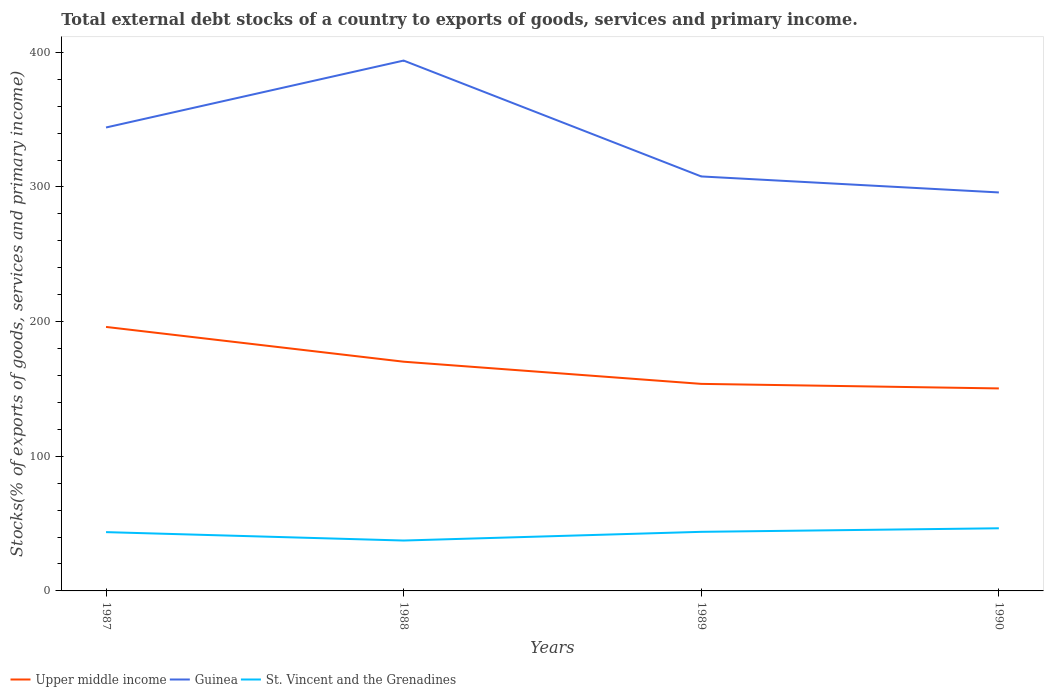How many different coloured lines are there?
Your answer should be very brief. 3. Across all years, what is the maximum total debt stocks in St. Vincent and the Grenadines?
Your answer should be very brief. 37.43. What is the total total debt stocks in St. Vincent and the Grenadines in the graph?
Offer a very short reply. -0.23. What is the difference between the highest and the second highest total debt stocks in Upper middle income?
Your answer should be very brief. 45.66. What is the difference between the highest and the lowest total debt stocks in St. Vincent and the Grenadines?
Make the answer very short. 3. How many lines are there?
Provide a short and direct response. 3. How many years are there in the graph?
Keep it short and to the point. 4. What is the difference between two consecutive major ticks on the Y-axis?
Make the answer very short. 100. Does the graph contain any zero values?
Provide a short and direct response. No. Does the graph contain grids?
Ensure brevity in your answer.  No. How many legend labels are there?
Offer a terse response. 3. What is the title of the graph?
Give a very brief answer. Total external debt stocks of a country to exports of goods, services and primary income. What is the label or title of the X-axis?
Make the answer very short. Years. What is the label or title of the Y-axis?
Make the answer very short. Stocks(% of exports of goods, services and primary income). What is the Stocks(% of exports of goods, services and primary income) in Upper middle income in 1987?
Offer a terse response. 196.06. What is the Stocks(% of exports of goods, services and primary income) of Guinea in 1987?
Ensure brevity in your answer.  344.19. What is the Stocks(% of exports of goods, services and primary income) in St. Vincent and the Grenadines in 1987?
Your answer should be very brief. 43.66. What is the Stocks(% of exports of goods, services and primary income) of Upper middle income in 1988?
Keep it short and to the point. 170.24. What is the Stocks(% of exports of goods, services and primary income) in Guinea in 1988?
Keep it short and to the point. 393.89. What is the Stocks(% of exports of goods, services and primary income) in St. Vincent and the Grenadines in 1988?
Provide a succinct answer. 37.43. What is the Stocks(% of exports of goods, services and primary income) in Upper middle income in 1989?
Make the answer very short. 153.77. What is the Stocks(% of exports of goods, services and primary income) in Guinea in 1989?
Offer a very short reply. 307.83. What is the Stocks(% of exports of goods, services and primary income) of St. Vincent and the Grenadines in 1989?
Your answer should be very brief. 43.89. What is the Stocks(% of exports of goods, services and primary income) in Upper middle income in 1990?
Offer a very short reply. 150.4. What is the Stocks(% of exports of goods, services and primary income) of Guinea in 1990?
Give a very brief answer. 295.95. What is the Stocks(% of exports of goods, services and primary income) in St. Vincent and the Grenadines in 1990?
Make the answer very short. 46.52. Across all years, what is the maximum Stocks(% of exports of goods, services and primary income) of Upper middle income?
Provide a succinct answer. 196.06. Across all years, what is the maximum Stocks(% of exports of goods, services and primary income) of Guinea?
Provide a succinct answer. 393.89. Across all years, what is the maximum Stocks(% of exports of goods, services and primary income) in St. Vincent and the Grenadines?
Give a very brief answer. 46.52. Across all years, what is the minimum Stocks(% of exports of goods, services and primary income) of Upper middle income?
Offer a very short reply. 150.4. Across all years, what is the minimum Stocks(% of exports of goods, services and primary income) in Guinea?
Your answer should be compact. 295.95. Across all years, what is the minimum Stocks(% of exports of goods, services and primary income) in St. Vincent and the Grenadines?
Ensure brevity in your answer.  37.43. What is the total Stocks(% of exports of goods, services and primary income) in Upper middle income in the graph?
Offer a terse response. 670.47. What is the total Stocks(% of exports of goods, services and primary income) of Guinea in the graph?
Your answer should be very brief. 1341.86. What is the total Stocks(% of exports of goods, services and primary income) of St. Vincent and the Grenadines in the graph?
Provide a short and direct response. 171.51. What is the difference between the Stocks(% of exports of goods, services and primary income) of Upper middle income in 1987 and that in 1988?
Offer a terse response. 25.82. What is the difference between the Stocks(% of exports of goods, services and primary income) in Guinea in 1987 and that in 1988?
Your answer should be compact. -49.7. What is the difference between the Stocks(% of exports of goods, services and primary income) in St. Vincent and the Grenadines in 1987 and that in 1988?
Your answer should be very brief. 6.23. What is the difference between the Stocks(% of exports of goods, services and primary income) of Upper middle income in 1987 and that in 1989?
Your answer should be compact. 42.29. What is the difference between the Stocks(% of exports of goods, services and primary income) of Guinea in 1987 and that in 1989?
Give a very brief answer. 36.36. What is the difference between the Stocks(% of exports of goods, services and primary income) in St. Vincent and the Grenadines in 1987 and that in 1989?
Offer a very short reply. -0.23. What is the difference between the Stocks(% of exports of goods, services and primary income) of Upper middle income in 1987 and that in 1990?
Offer a terse response. 45.66. What is the difference between the Stocks(% of exports of goods, services and primary income) of Guinea in 1987 and that in 1990?
Your answer should be very brief. 48.24. What is the difference between the Stocks(% of exports of goods, services and primary income) of St. Vincent and the Grenadines in 1987 and that in 1990?
Offer a terse response. -2.86. What is the difference between the Stocks(% of exports of goods, services and primary income) in Upper middle income in 1988 and that in 1989?
Provide a short and direct response. 16.47. What is the difference between the Stocks(% of exports of goods, services and primary income) of Guinea in 1988 and that in 1989?
Your response must be concise. 86.06. What is the difference between the Stocks(% of exports of goods, services and primary income) of St. Vincent and the Grenadines in 1988 and that in 1989?
Your response must be concise. -6.46. What is the difference between the Stocks(% of exports of goods, services and primary income) of Upper middle income in 1988 and that in 1990?
Your answer should be very brief. 19.84. What is the difference between the Stocks(% of exports of goods, services and primary income) of Guinea in 1988 and that in 1990?
Your answer should be compact. 97.94. What is the difference between the Stocks(% of exports of goods, services and primary income) in St. Vincent and the Grenadines in 1988 and that in 1990?
Your answer should be compact. -9.09. What is the difference between the Stocks(% of exports of goods, services and primary income) in Upper middle income in 1989 and that in 1990?
Offer a terse response. 3.37. What is the difference between the Stocks(% of exports of goods, services and primary income) of Guinea in 1989 and that in 1990?
Ensure brevity in your answer.  11.88. What is the difference between the Stocks(% of exports of goods, services and primary income) in St. Vincent and the Grenadines in 1989 and that in 1990?
Give a very brief answer. -2.63. What is the difference between the Stocks(% of exports of goods, services and primary income) in Upper middle income in 1987 and the Stocks(% of exports of goods, services and primary income) in Guinea in 1988?
Offer a terse response. -197.83. What is the difference between the Stocks(% of exports of goods, services and primary income) of Upper middle income in 1987 and the Stocks(% of exports of goods, services and primary income) of St. Vincent and the Grenadines in 1988?
Ensure brevity in your answer.  158.63. What is the difference between the Stocks(% of exports of goods, services and primary income) of Guinea in 1987 and the Stocks(% of exports of goods, services and primary income) of St. Vincent and the Grenadines in 1988?
Your response must be concise. 306.76. What is the difference between the Stocks(% of exports of goods, services and primary income) in Upper middle income in 1987 and the Stocks(% of exports of goods, services and primary income) in Guinea in 1989?
Provide a succinct answer. -111.77. What is the difference between the Stocks(% of exports of goods, services and primary income) in Upper middle income in 1987 and the Stocks(% of exports of goods, services and primary income) in St. Vincent and the Grenadines in 1989?
Offer a terse response. 152.17. What is the difference between the Stocks(% of exports of goods, services and primary income) in Guinea in 1987 and the Stocks(% of exports of goods, services and primary income) in St. Vincent and the Grenadines in 1989?
Keep it short and to the point. 300.3. What is the difference between the Stocks(% of exports of goods, services and primary income) in Upper middle income in 1987 and the Stocks(% of exports of goods, services and primary income) in Guinea in 1990?
Keep it short and to the point. -99.89. What is the difference between the Stocks(% of exports of goods, services and primary income) of Upper middle income in 1987 and the Stocks(% of exports of goods, services and primary income) of St. Vincent and the Grenadines in 1990?
Make the answer very short. 149.54. What is the difference between the Stocks(% of exports of goods, services and primary income) in Guinea in 1987 and the Stocks(% of exports of goods, services and primary income) in St. Vincent and the Grenadines in 1990?
Keep it short and to the point. 297.67. What is the difference between the Stocks(% of exports of goods, services and primary income) of Upper middle income in 1988 and the Stocks(% of exports of goods, services and primary income) of Guinea in 1989?
Provide a short and direct response. -137.59. What is the difference between the Stocks(% of exports of goods, services and primary income) in Upper middle income in 1988 and the Stocks(% of exports of goods, services and primary income) in St. Vincent and the Grenadines in 1989?
Provide a succinct answer. 126.35. What is the difference between the Stocks(% of exports of goods, services and primary income) in Guinea in 1988 and the Stocks(% of exports of goods, services and primary income) in St. Vincent and the Grenadines in 1989?
Make the answer very short. 350. What is the difference between the Stocks(% of exports of goods, services and primary income) in Upper middle income in 1988 and the Stocks(% of exports of goods, services and primary income) in Guinea in 1990?
Provide a succinct answer. -125.71. What is the difference between the Stocks(% of exports of goods, services and primary income) in Upper middle income in 1988 and the Stocks(% of exports of goods, services and primary income) in St. Vincent and the Grenadines in 1990?
Make the answer very short. 123.72. What is the difference between the Stocks(% of exports of goods, services and primary income) of Guinea in 1988 and the Stocks(% of exports of goods, services and primary income) of St. Vincent and the Grenadines in 1990?
Ensure brevity in your answer.  347.37. What is the difference between the Stocks(% of exports of goods, services and primary income) of Upper middle income in 1989 and the Stocks(% of exports of goods, services and primary income) of Guinea in 1990?
Offer a very short reply. -142.18. What is the difference between the Stocks(% of exports of goods, services and primary income) in Upper middle income in 1989 and the Stocks(% of exports of goods, services and primary income) in St. Vincent and the Grenadines in 1990?
Your answer should be compact. 107.25. What is the difference between the Stocks(% of exports of goods, services and primary income) in Guinea in 1989 and the Stocks(% of exports of goods, services and primary income) in St. Vincent and the Grenadines in 1990?
Provide a short and direct response. 261.31. What is the average Stocks(% of exports of goods, services and primary income) in Upper middle income per year?
Make the answer very short. 167.62. What is the average Stocks(% of exports of goods, services and primary income) in Guinea per year?
Give a very brief answer. 335.46. What is the average Stocks(% of exports of goods, services and primary income) of St. Vincent and the Grenadines per year?
Your answer should be very brief. 42.88. In the year 1987, what is the difference between the Stocks(% of exports of goods, services and primary income) in Upper middle income and Stocks(% of exports of goods, services and primary income) in Guinea?
Provide a succinct answer. -148.13. In the year 1987, what is the difference between the Stocks(% of exports of goods, services and primary income) of Upper middle income and Stocks(% of exports of goods, services and primary income) of St. Vincent and the Grenadines?
Your answer should be very brief. 152.4. In the year 1987, what is the difference between the Stocks(% of exports of goods, services and primary income) of Guinea and Stocks(% of exports of goods, services and primary income) of St. Vincent and the Grenadines?
Your response must be concise. 300.53. In the year 1988, what is the difference between the Stocks(% of exports of goods, services and primary income) of Upper middle income and Stocks(% of exports of goods, services and primary income) of Guinea?
Offer a terse response. -223.65. In the year 1988, what is the difference between the Stocks(% of exports of goods, services and primary income) in Upper middle income and Stocks(% of exports of goods, services and primary income) in St. Vincent and the Grenadines?
Keep it short and to the point. 132.81. In the year 1988, what is the difference between the Stocks(% of exports of goods, services and primary income) in Guinea and Stocks(% of exports of goods, services and primary income) in St. Vincent and the Grenadines?
Provide a short and direct response. 356.46. In the year 1989, what is the difference between the Stocks(% of exports of goods, services and primary income) of Upper middle income and Stocks(% of exports of goods, services and primary income) of Guinea?
Your answer should be compact. -154.06. In the year 1989, what is the difference between the Stocks(% of exports of goods, services and primary income) in Upper middle income and Stocks(% of exports of goods, services and primary income) in St. Vincent and the Grenadines?
Offer a very short reply. 109.88. In the year 1989, what is the difference between the Stocks(% of exports of goods, services and primary income) of Guinea and Stocks(% of exports of goods, services and primary income) of St. Vincent and the Grenadines?
Provide a short and direct response. 263.94. In the year 1990, what is the difference between the Stocks(% of exports of goods, services and primary income) of Upper middle income and Stocks(% of exports of goods, services and primary income) of Guinea?
Give a very brief answer. -145.55. In the year 1990, what is the difference between the Stocks(% of exports of goods, services and primary income) of Upper middle income and Stocks(% of exports of goods, services and primary income) of St. Vincent and the Grenadines?
Give a very brief answer. 103.88. In the year 1990, what is the difference between the Stocks(% of exports of goods, services and primary income) of Guinea and Stocks(% of exports of goods, services and primary income) of St. Vincent and the Grenadines?
Offer a very short reply. 249.43. What is the ratio of the Stocks(% of exports of goods, services and primary income) in Upper middle income in 1987 to that in 1988?
Offer a very short reply. 1.15. What is the ratio of the Stocks(% of exports of goods, services and primary income) of Guinea in 1987 to that in 1988?
Give a very brief answer. 0.87. What is the ratio of the Stocks(% of exports of goods, services and primary income) in St. Vincent and the Grenadines in 1987 to that in 1988?
Offer a very short reply. 1.17. What is the ratio of the Stocks(% of exports of goods, services and primary income) in Upper middle income in 1987 to that in 1989?
Give a very brief answer. 1.27. What is the ratio of the Stocks(% of exports of goods, services and primary income) of Guinea in 1987 to that in 1989?
Give a very brief answer. 1.12. What is the ratio of the Stocks(% of exports of goods, services and primary income) of Upper middle income in 1987 to that in 1990?
Provide a succinct answer. 1.3. What is the ratio of the Stocks(% of exports of goods, services and primary income) of Guinea in 1987 to that in 1990?
Provide a short and direct response. 1.16. What is the ratio of the Stocks(% of exports of goods, services and primary income) of St. Vincent and the Grenadines in 1987 to that in 1990?
Provide a succinct answer. 0.94. What is the ratio of the Stocks(% of exports of goods, services and primary income) in Upper middle income in 1988 to that in 1989?
Offer a terse response. 1.11. What is the ratio of the Stocks(% of exports of goods, services and primary income) of Guinea in 1988 to that in 1989?
Offer a terse response. 1.28. What is the ratio of the Stocks(% of exports of goods, services and primary income) of St. Vincent and the Grenadines in 1988 to that in 1989?
Make the answer very short. 0.85. What is the ratio of the Stocks(% of exports of goods, services and primary income) of Upper middle income in 1988 to that in 1990?
Your answer should be compact. 1.13. What is the ratio of the Stocks(% of exports of goods, services and primary income) of Guinea in 1988 to that in 1990?
Provide a short and direct response. 1.33. What is the ratio of the Stocks(% of exports of goods, services and primary income) of St. Vincent and the Grenadines in 1988 to that in 1990?
Your answer should be compact. 0.8. What is the ratio of the Stocks(% of exports of goods, services and primary income) of Upper middle income in 1989 to that in 1990?
Your response must be concise. 1.02. What is the ratio of the Stocks(% of exports of goods, services and primary income) in Guinea in 1989 to that in 1990?
Offer a terse response. 1.04. What is the ratio of the Stocks(% of exports of goods, services and primary income) in St. Vincent and the Grenadines in 1989 to that in 1990?
Provide a succinct answer. 0.94. What is the difference between the highest and the second highest Stocks(% of exports of goods, services and primary income) of Upper middle income?
Your answer should be compact. 25.82. What is the difference between the highest and the second highest Stocks(% of exports of goods, services and primary income) of Guinea?
Your answer should be compact. 49.7. What is the difference between the highest and the second highest Stocks(% of exports of goods, services and primary income) of St. Vincent and the Grenadines?
Make the answer very short. 2.63. What is the difference between the highest and the lowest Stocks(% of exports of goods, services and primary income) in Upper middle income?
Provide a succinct answer. 45.66. What is the difference between the highest and the lowest Stocks(% of exports of goods, services and primary income) in Guinea?
Make the answer very short. 97.94. What is the difference between the highest and the lowest Stocks(% of exports of goods, services and primary income) in St. Vincent and the Grenadines?
Offer a terse response. 9.09. 